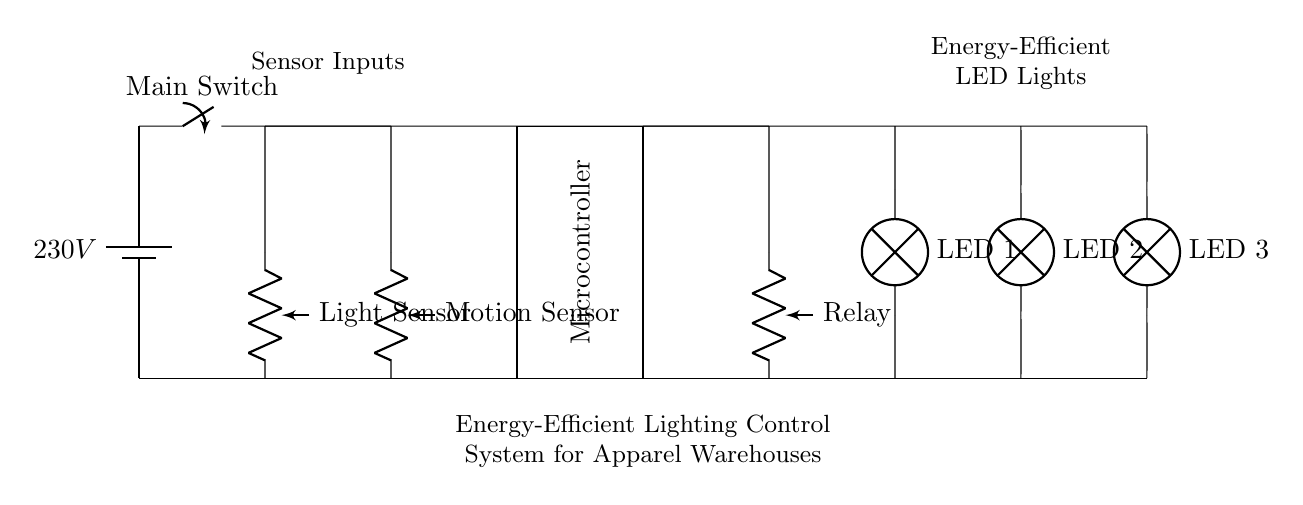What is the voltage of this circuit? The circuit is powered by a battery indicated as 230V at the top left corner.
Answer: 230V What types of sensors are used in this circuit? There are two types of sensors present: a Motion Sensor and a Light Sensor, both labeled in the circuit.
Answer: Motion Sensor, Light Sensor How many LED lights are connected to this circuit? The circuit diagram shows three LED lights connected at the bottom right, each labeled LED 1, LED 2, and LED 3.
Answer: Three What is the role of the Microcontroller in this circuit? The Microcontroller, located in the center, processes input from the sensors to control the operation of the lights based on the sensor data.
Answer: Control lighting Which component controls the electrical power to the LED lights? The Relay connected to the microcontroller acts as a switch, enabling or disabling the power to the LED lights.
Answer: Relay What is the purpose of the Motion Sensor in this lighting control system? The Motion Sensor detects movement within the warehouse, allowing the system to turn on the lights automatically when someone is present.
Answer: Detect movement Explain how the Light Sensor affects the operation of this circuit. The Light Sensor measures the brightness level in the warehouse. If it detects sufficient ambient light, it signals the microcontroller to keep the LED lights off, optimizing energy usage.
Answer: Optimize energy usage 